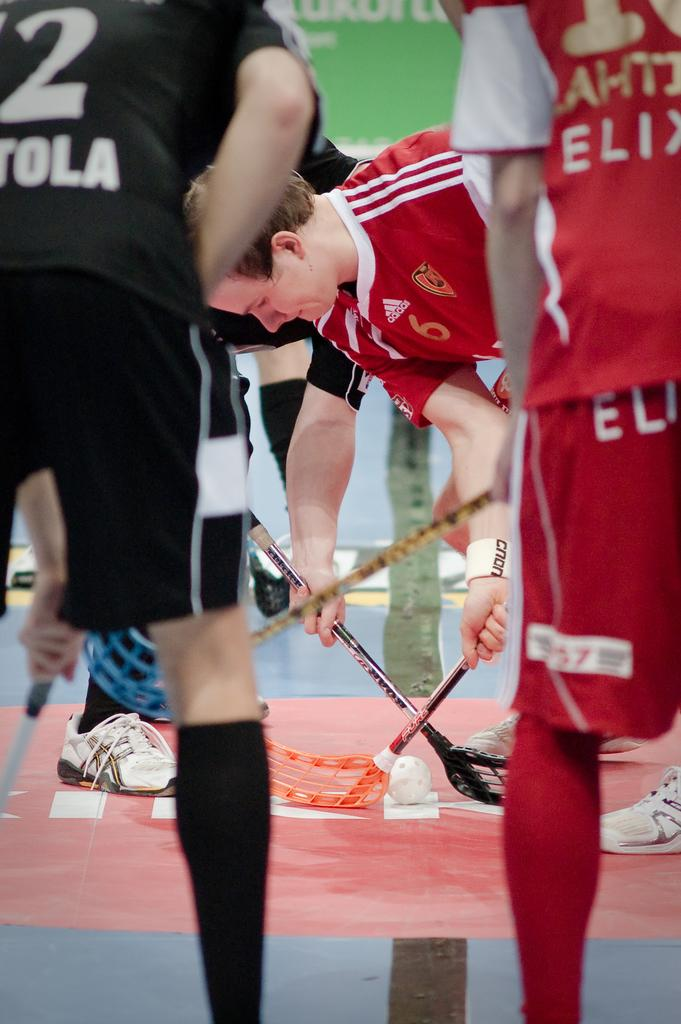<image>
Share a concise interpretation of the image provided. A man prepares to start the game while wearing a red Adidas jersey. 